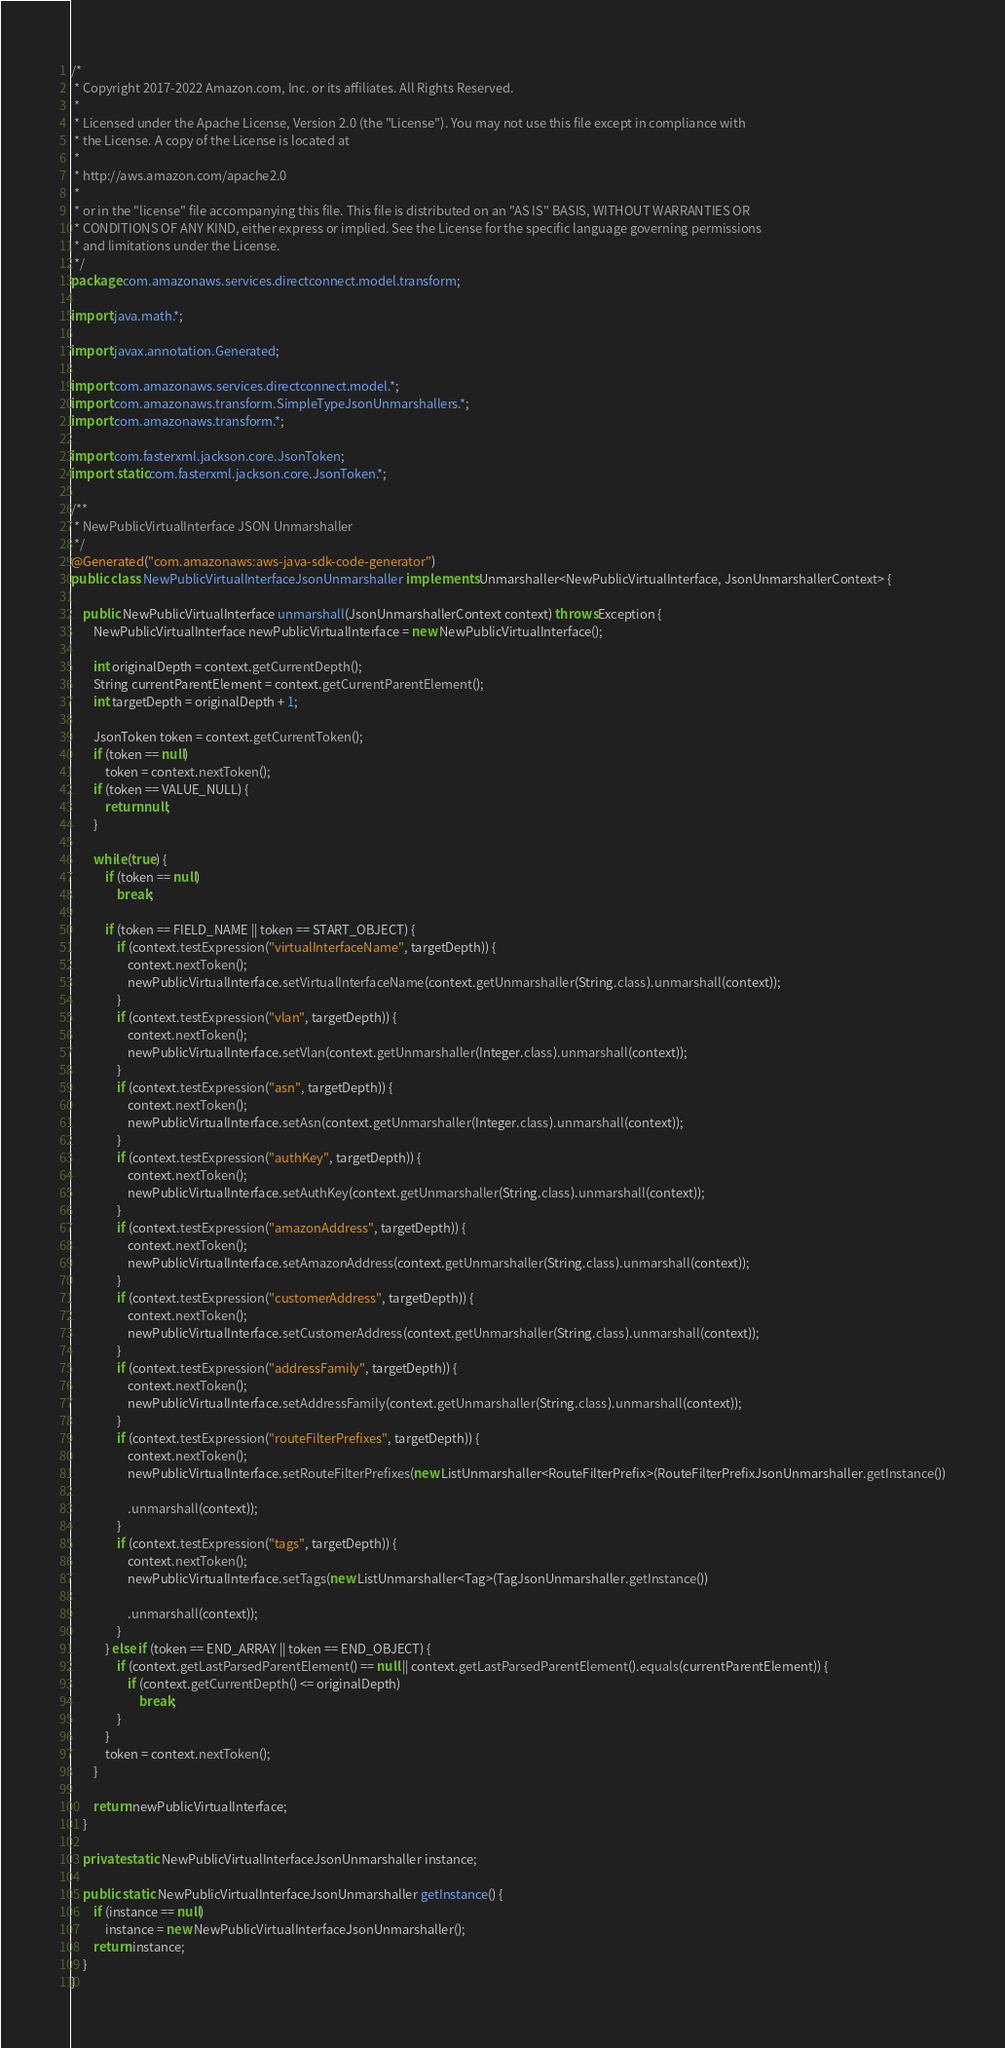Convert code to text. <code><loc_0><loc_0><loc_500><loc_500><_Java_>/*
 * Copyright 2017-2022 Amazon.com, Inc. or its affiliates. All Rights Reserved.
 * 
 * Licensed under the Apache License, Version 2.0 (the "License"). You may not use this file except in compliance with
 * the License. A copy of the License is located at
 * 
 * http://aws.amazon.com/apache2.0
 * 
 * or in the "license" file accompanying this file. This file is distributed on an "AS IS" BASIS, WITHOUT WARRANTIES OR
 * CONDITIONS OF ANY KIND, either express or implied. See the License for the specific language governing permissions
 * and limitations under the License.
 */
package com.amazonaws.services.directconnect.model.transform;

import java.math.*;

import javax.annotation.Generated;

import com.amazonaws.services.directconnect.model.*;
import com.amazonaws.transform.SimpleTypeJsonUnmarshallers.*;
import com.amazonaws.transform.*;

import com.fasterxml.jackson.core.JsonToken;
import static com.fasterxml.jackson.core.JsonToken.*;

/**
 * NewPublicVirtualInterface JSON Unmarshaller
 */
@Generated("com.amazonaws:aws-java-sdk-code-generator")
public class NewPublicVirtualInterfaceJsonUnmarshaller implements Unmarshaller<NewPublicVirtualInterface, JsonUnmarshallerContext> {

    public NewPublicVirtualInterface unmarshall(JsonUnmarshallerContext context) throws Exception {
        NewPublicVirtualInterface newPublicVirtualInterface = new NewPublicVirtualInterface();

        int originalDepth = context.getCurrentDepth();
        String currentParentElement = context.getCurrentParentElement();
        int targetDepth = originalDepth + 1;

        JsonToken token = context.getCurrentToken();
        if (token == null)
            token = context.nextToken();
        if (token == VALUE_NULL) {
            return null;
        }

        while (true) {
            if (token == null)
                break;

            if (token == FIELD_NAME || token == START_OBJECT) {
                if (context.testExpression("virtualInterfaceName", targetDepth)) {
                    context.nextToken();
                    newPublicVirtualInterface.setVirtualInterfaceName(context.getUnmarshaller(String.class).unmarshall(context));
                }
                if (context.testExpression("vlan", targetDepth)) {
                    context.nextToken();
                    newPublicVirtualInterface.setVlan(context.getUnmarshaller(Integer.class).unmarshall(context));
                }
                if (context.testExpression("asn", targetDepth)) {
                    context.nextToken();
                    newPublicVirtualInterface.setAsn(context.getUnmarshaller(Integer.class).unmarshall(context));
                }
                if (context.testExpression("authKey", targetDepth)) {
                    context.nextToken();
                    newPublicVirtualInterface.setAuthKey(context.getUnmarshaller(String.class).unmarshall(context));
                }
                if (context.testExpression("amazonAddress", targetDepth)) {
                    context.nextToken();
                    newPublicVirtualInterface.setAmazonAddress(context.getUnmarshaller(String.class).unmarshall(context));
                }
                if (context.testExpression("customerAddress", targetDepth)) {
                    context.nextToken();
                    newPublicVirtualInterface.setCustomerAddress(context.getUnmarshaller(String.class).unmarshall(context));
                }
                if (context.testExpression("addressFamily", targetDepth)) {
                    context.nextToken();
                    newPublicVirtualInterface.setAddressFamily(context.getUnmarshaller(String.class).unmarshall(context));
                }
                if (context.testExpression("routeFilterPrefixes", targetDepth)) {
                    context.nextToken();
                    newPublicVirtualInterface.setRouteFilterPrefixes(new ListUnmarshaller<RouteFilterPrefix>(RouteFilterPrefixJsonUnmarshaller.getInstance())

                    .unmarshall(context));
                }
                if (context.testExpression("tags", targetDepth)) {
                    context.nextToken();
                    newPublicVirtualInterface.setTags(new ListUnmarshaller<Tag>(TagJsonUnmarshaller.getInstance())

                    .unmarshall(context));
                }
            } else if (token == END_ARRAY || token == END_OBJECT) {
                if (context.getLastParsedParentElement() == null || context.getLastParsedParentElement().equals(currentParentElement)) {
                    if (context.getCurrentDepth() <= originalDepth)
                        break;
                }
            }
            token = context.nextToken();
        }

        return newPublicVirtualInterface;
    }

    private static NewPublicVirtualInterfaceJsonUnmarshaller instance;

    public static NewPublicVirtualInterfaceJsonUnmarshaller getInstance() {
        if (instance == null)
            instance = new NewPublicVirtualInterfaceJsonUnmarshaller();
        return instance;
    }
}
</code> 